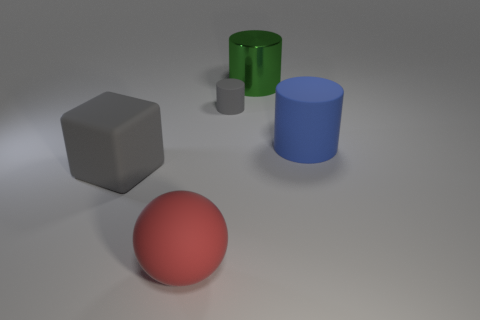Add 3 cyan rubber objects. How many objects exist? 8 Subtract all balls. How many objects are left? 4 Subtract all big green matte things. Subtract all blue matte cylinders. How many objects are left? 4 Add 1 big green shiny objects. How many big green shiny objects are left? 2 Add 4 balls. How many balls exist? 5 Subtract 1 green cylinders. How many objects are left? 4 